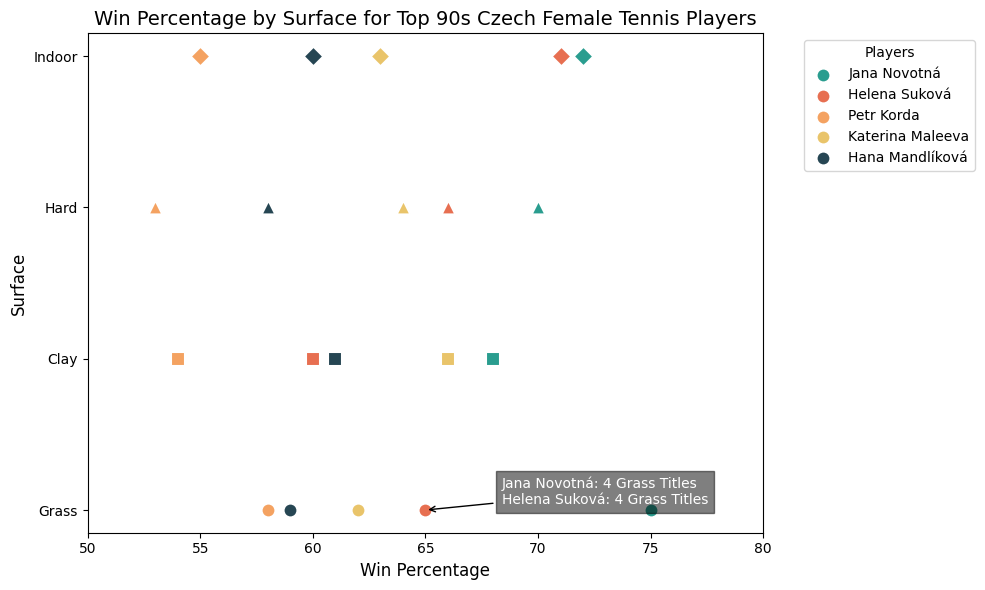What is the highest win percentage on grass for any player? By looking at the plot, the highest win percentage on grass corresponds to Jana Novotná with a win percentage of 75%.
Answer: 75% Which player has the highest win percentage on indoor surfaces, and what is their percentage? Observing the scatter plot, Helena Suková has the highest win percentage on indoor surfaces at 71%.
Answer: Helena Suková, 71% How many grass titles have Jana Novotná and Helena Suková won combined? Referring to the annotation text provided in the scatter plot, Jana Novotná has won 4 grass titles, and so has Helena Suková. Therefore, combined they have won 4 + 4 = 8 grass titles.
Answer: 8 Which surface shows the smallest variation in win percentages for Jana Novotná and Helena Suková, and what are the percentages? To find this, we need to compare the win percentages of Jana Novotná and Helena Suková across different surfaces. Grass: 75% and 65%, Clay: 68% and 60%, Hard: 70% and 66%, Indoor: 72% and 71%. The smallest variation is on Indoor surfaces where both have win percentages of 72% and 71%.
Answer: Indoor, 72% and 71% Which player has the lowest win percentage on any surface, and what is that percentage? The lowest win percentage depicted in the plot is for Petr Korda on hard surfaces with a win percentage of 53%.
Answer: Petr Korda, 53% What is the average win percentage on clay surfaces for all players? To calculate it, we sum the win percentages on clay for all players and divide by the number of players (68 + 60 + 54 + 66 + 61) / 5 = 309 / 5 = 61.8.
Answer: 61.8 What is the difference in win percentages on grass between Jana Novotná and every other player? Counting from the highest to lowest: Jana Novotná (75%) - Helena Suková (65%) = 10%, Jana Novotná (75%) - Katerina Maleeva (62%) = 13%, Jana Novotná (75%) - Hana Mandlíková (59%) = 16%, and Jana Novotná (75%) - Petr Korda (58%) = 17%. So, the differences are 10%, 13%, 16%, and 17% respectively.
Answer: 10%, 13%, 16%, 17% On which surface do both Jana Novotná and Helena Suková have the same number of titles, and how many titles do they have on that surface? According to the annotation on the figure, both Jana Novotná and Helena Suková have the same number of titles on Grass, which is 4 titles each.
Answer: Grass, 4 Which player is used as a reference point in the annotation, and what specific information is provided about them? The annotation references both Jana Novotná and Helena Suková, providing the number of grass titles each has won: 4 for Jana Novotná and 4 for Helena Suková.
Answer: Jana Novotná and Helena Suková, Grass Titles 